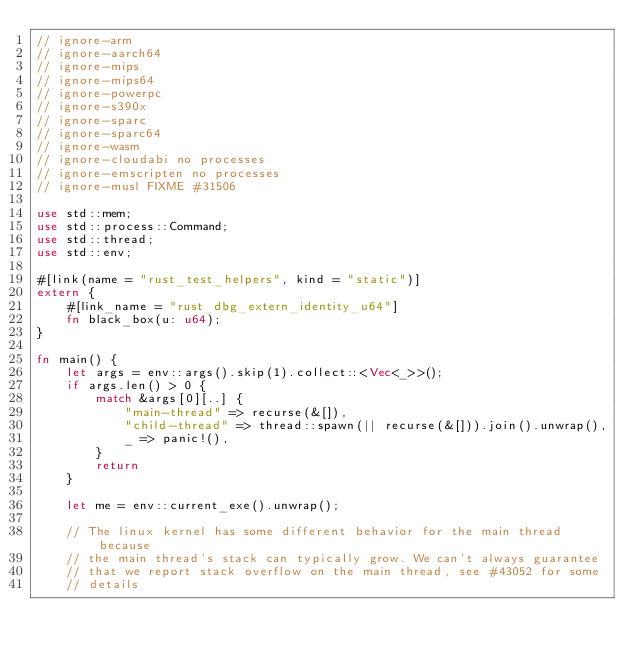Convert code to text. <code><loc_0><loc_0><loc_500><loc_500><_Rust_>// ignore-arm
// ignore-aarch64
// ignore-mips
// ignore-mips64
// ignore-powerpc
// ignore-s390x
// ignore-sparc
// ignore-sparc64
// ignore-wasm
// ignore-cloudabi no processes
// ignore-emscripten no processes
// ignore-musl FIXME #31506

use std::mem;
use std::process::Command;
use std::thread;
use std::env;

#[link(name = "rust_test_helpers", kind = "static")]
extern {
    #[link_name = "rust_dbg_extern_identity_u64"]
    fn black_box(u: u64);
}

fn main() {
    let args = env::args().skip(1).collect::<Vec<_>>();
    if args.len() > 0 {
        match &args[0][..] {
            "main-thread" => recurse(&[]),
            "child-thread" => thread::spawn(|| recurse(&[])).join().unwrap(),
            _ => panic!(),
        }
        return
    }

    let me = env::current_exe().unwrap();

    // The linux kernel has some different behavior for the main thread because
    // the main thread's stack can typically grow. We can't always guarantee
    // that we report stack overflow on the main thread, see #43052 for some
    // details</code> 